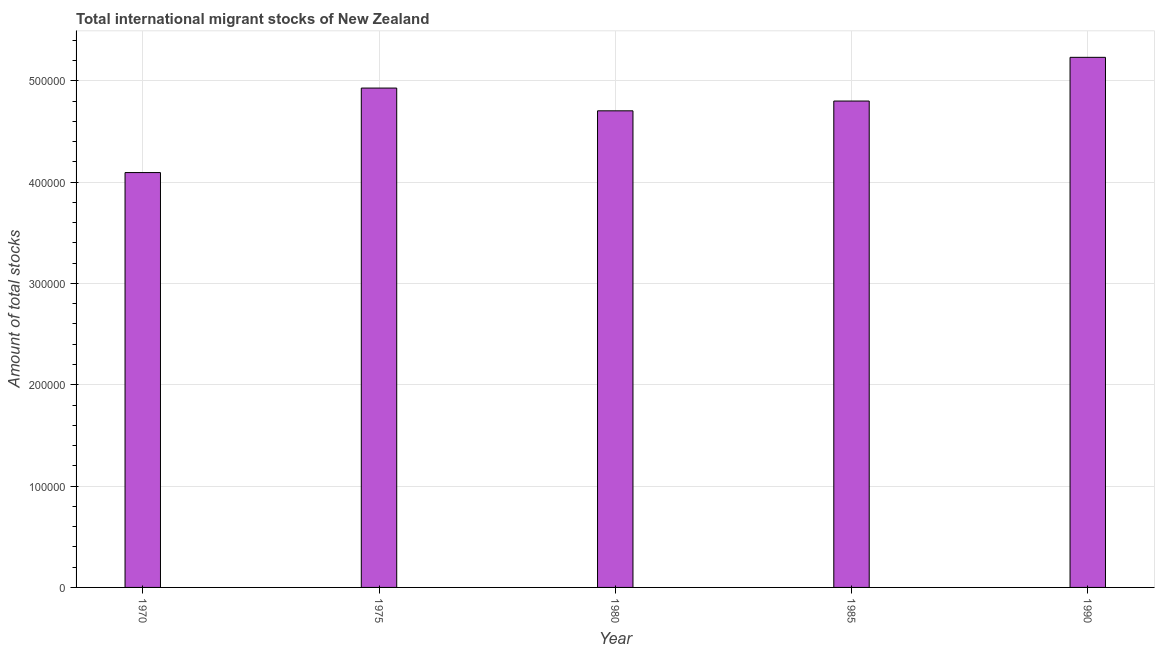Does the graph contain grids?
Your answer should be compact. Yes. What is the title of the graph?
Your response must be concise. Total international migrant stocks of New Zealand. What is the label or title of the X-axis?
Make the answer very short. Year. What is the label or title of the Y-axis?
Give a very brief answer. Amount of total stocks. What is the total number of international migrant stock in 1985?
Provide a short and direct response. 4.80e+05. Across all years, what is the maximum total number of international migrant stock?
Make the answer very short. 5.23e+05. Across all years, what is the minimum total number of international migrant stock?
Provide a short and direct response. 4.09e+05. In which year was the total number of international migrant stock minimum?
Your answer should be very brief. 1970. What is the sum of the total number of international migrant stock?
Provide a succinct answer. 2.38e+06. What is the difference between the total number of international migrant stock in 1970 and 1975?
Give a very brief answer. -8.34e+04. What is the average total number of international migrant stock per year?
Provide a short and direct response. 4.75e+05. What is the median total number of international migrant stock?
Your answer should be very brief. 4.80e+05. What is the difference between the highest and the second highest total number of international migrant stock?
Offer a terse response. 3.03e+04. Is the sum of the total number of international migrant stock in 1980 and 1990 greater than the maximum total number of international migrant stock across all years?
Your answer should be very brief. Yes. What is the difference between the highest and the lowest total number of international migrant stock?
Keep it short and to the point. 1.14e+05. In how many years, is the total number of international migrant stock greater than the average total number of international migrant stock taken over all years?
Offer a very short reply. 3. How many bars are there?
Provide a succinct answer. 5. What is the difference between two consecutive major ticks on the Y-axis?
Your answer should be very brief. 1.00e+05. What is the Amount of total stocks of 1970?
Offer a terse response. 4.09e+05. What is the Amount of total stocks in 1975?
Make the answer very short. 4.93e+05. What is the Amount of total stocks in 1980?
Ensure brevity in your answer.  4.70e+05. What is the Amount of total stocks of 1985?
Your response must be concise. 4.80e+05. What is the Amount of total stocks of 1990?
Your response must be concise. 5.23e+05. What is the difference between the Amount of total stocks in 1970 and 1975?
Offer a terse response. -8.34e+04. What is the difference between the Amount of total stocks in 1970 and 1980?
Your answer should be very brief. -6.09e+04. What is the difference between the Amount of total stocks in 1970 and 1985?
Ensure brevity in your answer.  -7.06e+04. What is the difference between the Amount of total stocks in 1970 and 1990?
Your answer should be compact. -1.14e+05. What is the difference between the Amount of total stocks in 1975 and 1980?
Offer a terse response. 2.25e+04. What is the difference between the Amount of total stocks in 1975 and 1985?
Your response must be concise. 1.28e+04. What is the difference between the Amount of total stocks in 1975 and 1990?
Provide a short and direct response. -3.03e+04. What is the difference between the Amount of total stocks in 1980 and 1985?
Ensure brevity in your answer.  -9649. What is the difference between the Amount of total stocks in 1980 and 1990?
Keep it short and to the point. -5.28e+04. What is the difference between the Amount of total stocks in 1985 and 1990?
Your answer should be compact. -4.31e+04. What is the ratio of the Amount of total stocks in 1970 to that in 1975?
Keep it short and to the point. 0.83. What is the ratio of the Amount of total stocks in 1970 to that in 1980?
Your response must be concise. 0.87. What is the ratio of the Amount of total stocks in 1970 to that in 1985?
Give a very brief answer. 0.85. What is the ratio of the Amount of total stocks in 1970 to that in 1990?
Your answer should be compact. 0.78. What is the ratio of the Amount of total stocks in 1975 to that in 1980?
Your answer should be very brief. 1.05. What is the ratio of the Amount of total stocks in 1975 to that in 1985?
Ensure brevity in your answer.  1.03. What is the ratio of the Amount of total stocks in 1975 to that in 1990?
Your answer should be very brief. 0.94. What is the ratio of the Amount of total stocks in 1980 to that in 1985?
Provide a succinct answer. 0.98. What is the ratio of the Amount of total stocks in 1980 to that in 1990?
Your answer should be very brief. 0.9. What is the ratio of the Amount of total stocks in 1985 to that in 1990?
Your response must be concise. 0.92. 